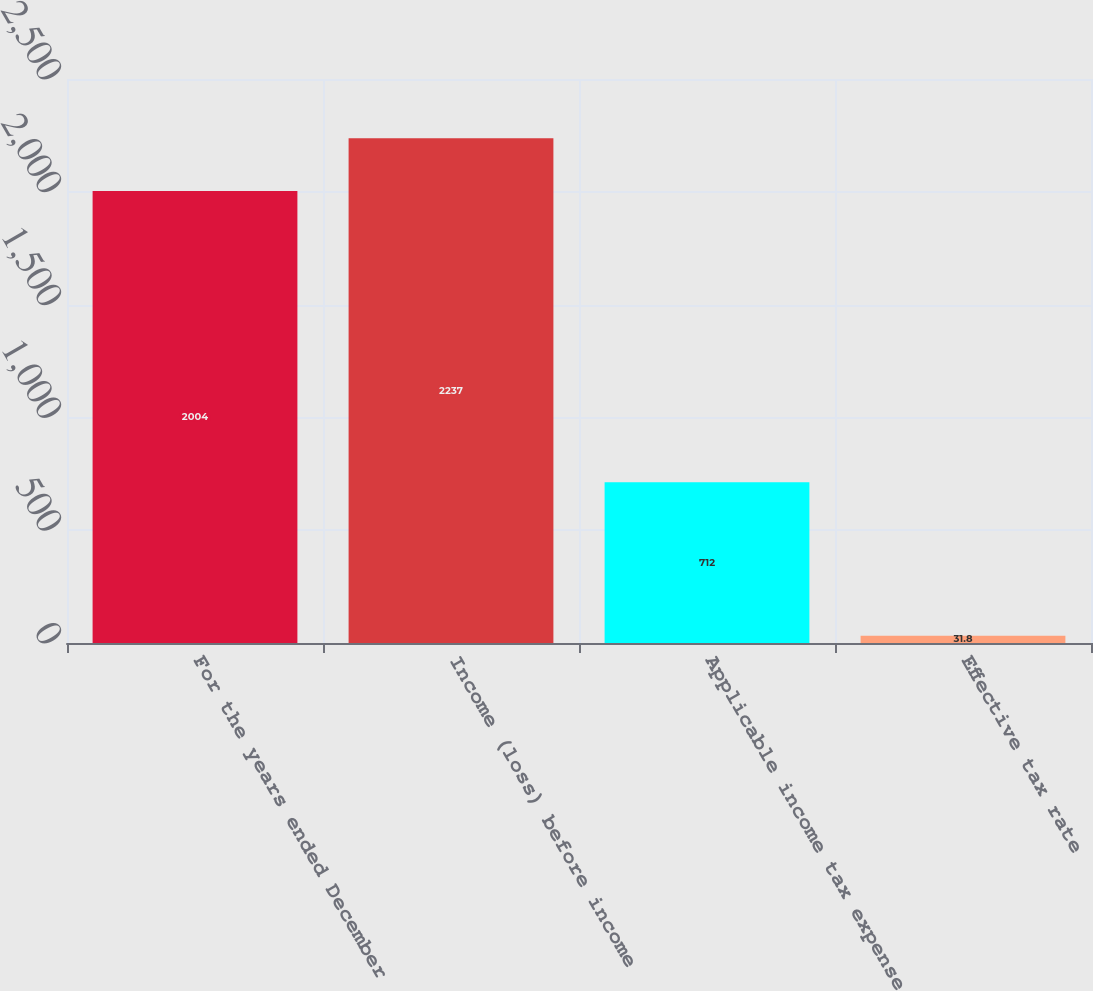<chart> <loc_0><loc_0><loc_500><loc_500><bar_chart><fcel>For the years ended December<fcel>Income (loss) before income<fcel>Applicable income tax expense<fcel>Effective tax rate<nl><fcel>2004<fcel>2237<fcel>712<fcel>31.8<nl></chart> 